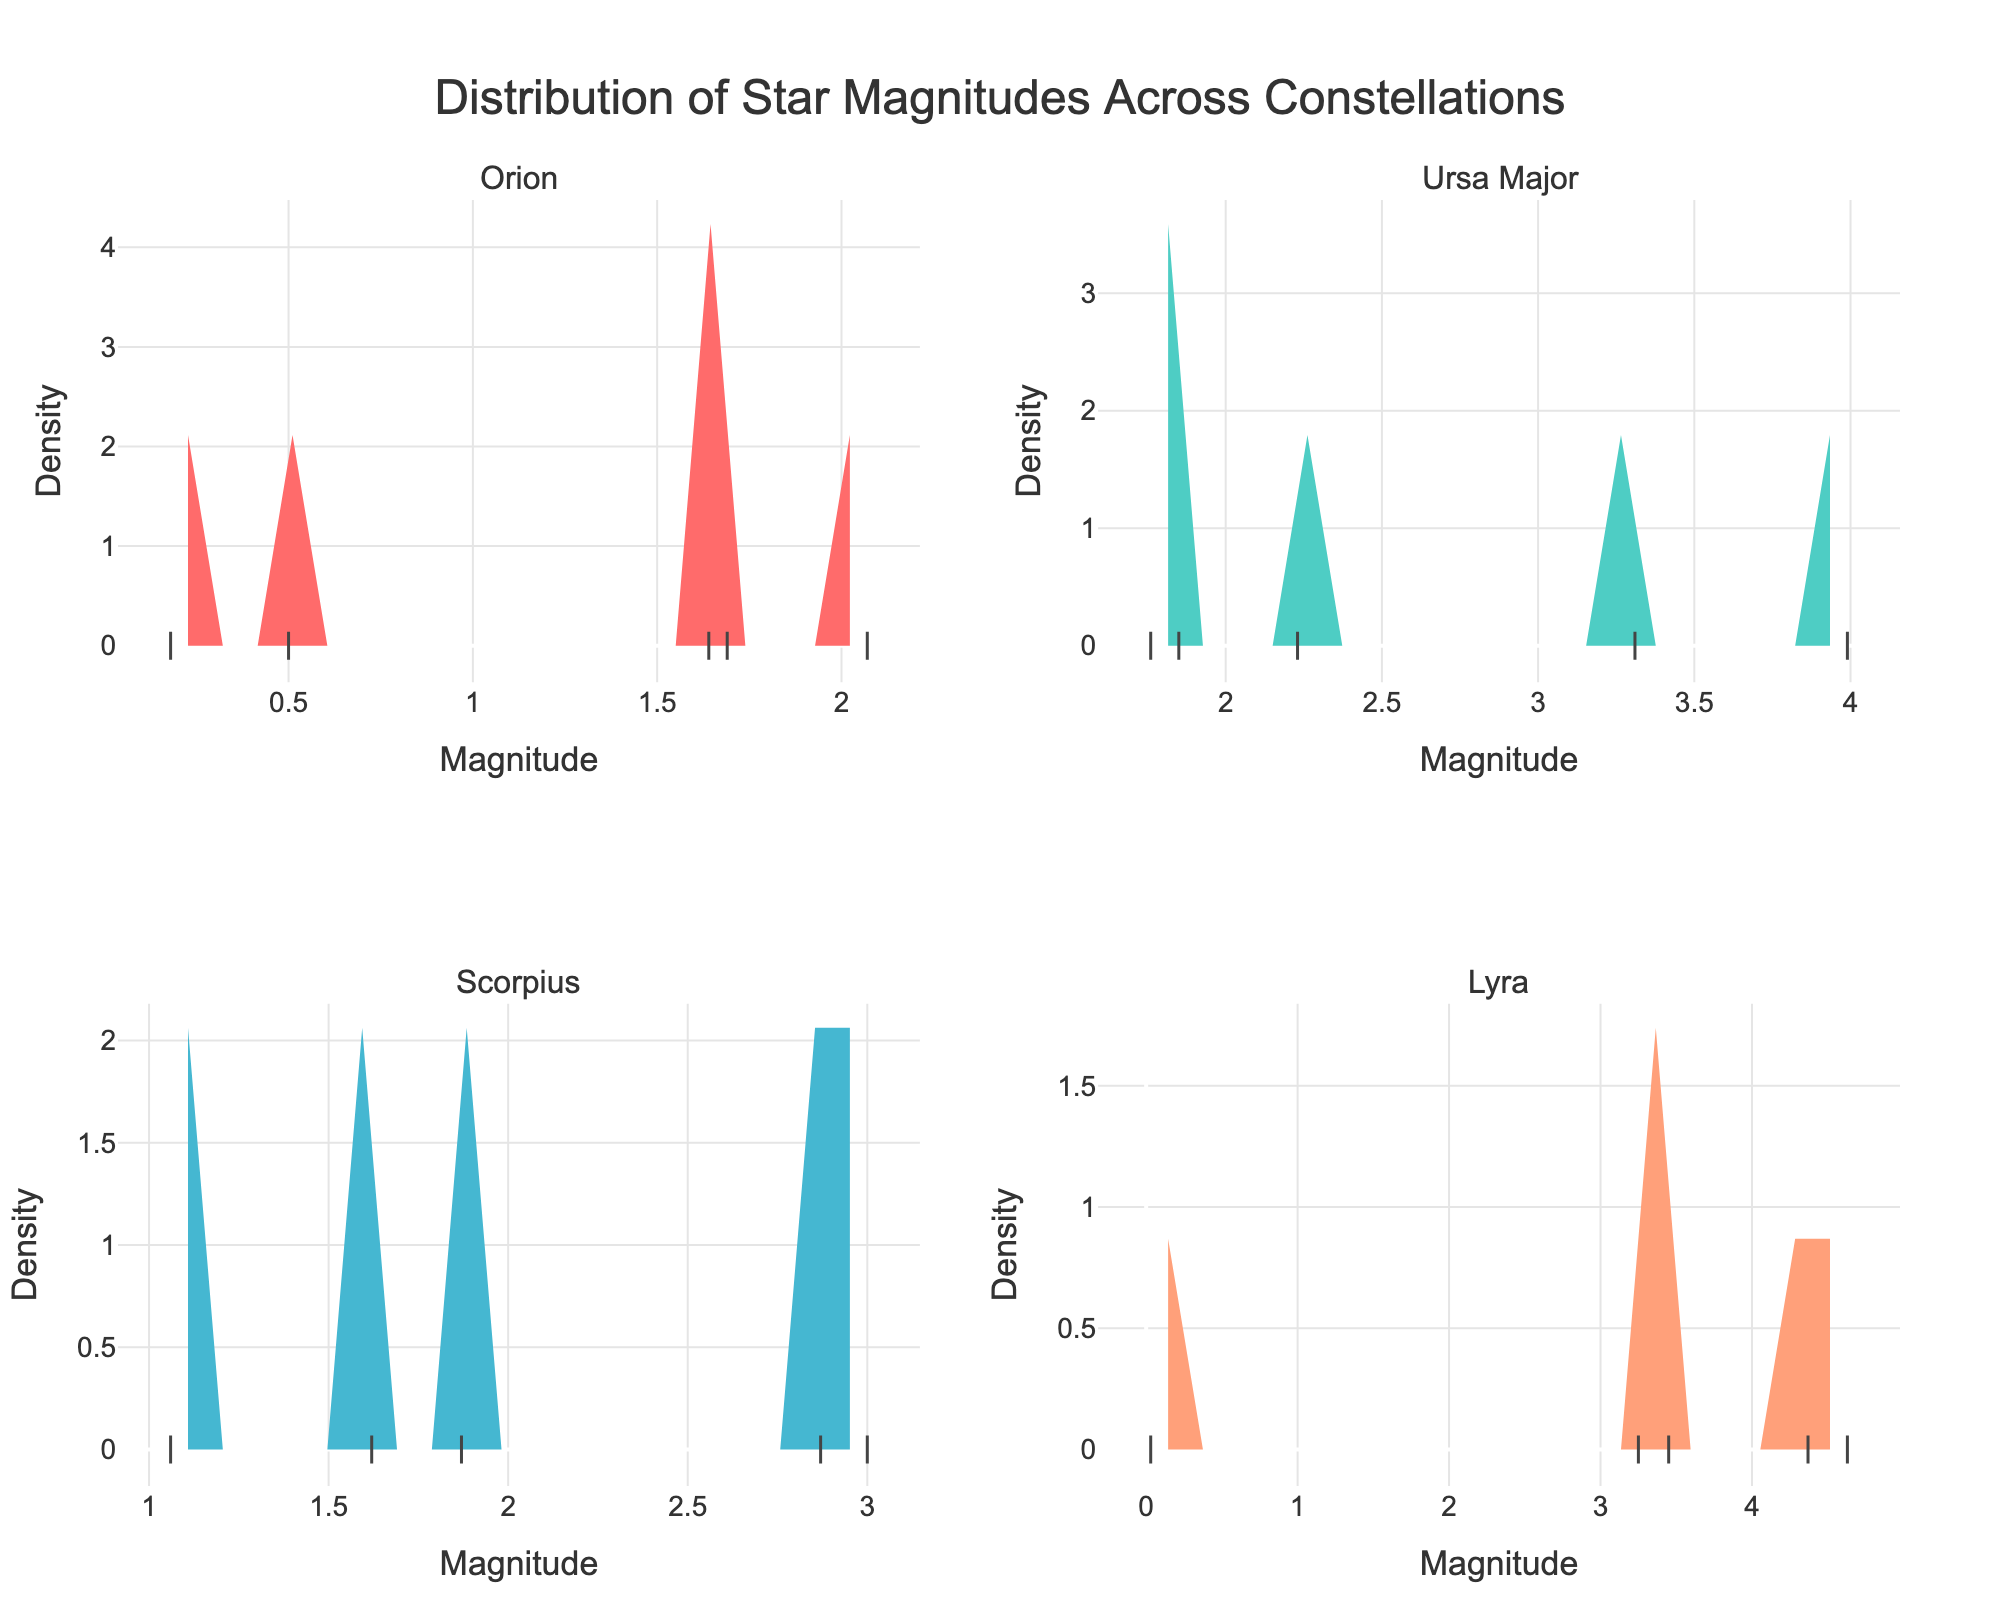What is the title of the figure? The title is located at the top center of the figure, typically in a larger and bold font. The title serves to provide a succinct summary of what the figure represents.
Answer: Distribution of Star Magnitudes Across Constellations Which constellation has the star with the lowest magnitude? By examining the individual points on the x-axis in each subplot, the star Vega in the Lyra constellation has the lowest magnitude at 0.03.
Answer: Lyra Which constellation shows the widest spread in star magnitudes? By comparing the range of star magnitudes in each subplot, Lyra has the widest spread of star magnitudes, ranging from approximately 0 to over 4.
Answer: Lyra In which subplot is the density peak closest to zero on the y-axis? By looking for the peak that is closest to the baseline on the y-axis among all subplots, Lyra has the lowest peak density.
Answer: Lyra What is the largest density value observed in the Ursa Major constellation subplot? Identifying the highest point on the density line in the Ursa Major subplot, the largest density observed is approximately 0.8.
Answer: Approximately 0.8 Which constellation has the most tightly clustered magnitudes around a single value? Assessing the constellations with the narrowest and highest density peak, Orion shows tightly clustered magnitudes around a peak near 1.75.
Answer: Orion Compare the highest density values of Orion and Scorpius. Which one is greater? By comparing the peaks of the density curves for both subplots, Orion has a higher peak density than Scorpius.
Answer: Orion How many stars are shown for each constellation? Counting the number of points representing individual stars in each subplot, we find 5 stars for Orion, 5 for Ursa Major, 5 for Scorpius, and 5 for Lyra.
Answer: 5 stars each What is the mean magnitude of stars in the Orion constellation? The mean magnitude is calculated by summing the magnitudes (0.50, 0.18, 1.64, 2.07, 1.69) and dividing by the number of stars (5). (0.50 + 0.18 + 1.64 + 2.07 + 1.69) / 5 = 1.216
Answer: 1.216 